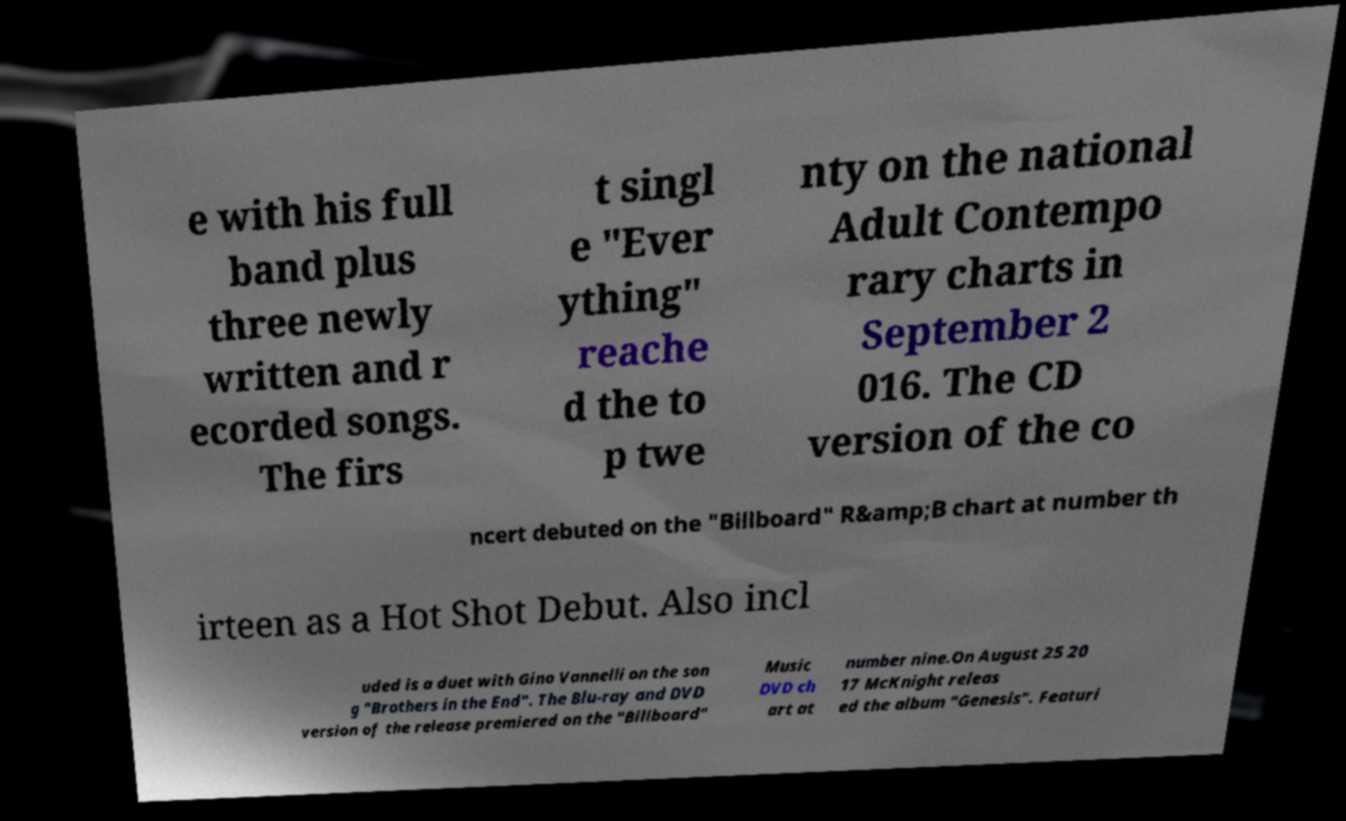There's text embedded in this image that I need extracted. Can you transcribe it verbatim? e with his full band plus three newly written and r ecorded songs. The firs t singl e "Ever ything" reache d the to p twe nty on the national Adult Contempo rary charts in September 2 016. The CD version of the co ncert debuted on the "Billboard" R&amp;B chart at number th irteen as a Hot Shot Debut. Also incl uded is a duet with Gino Vannelli on the son g "Brothers in the End". The Blu-ray and DVD version of the release premiered on the "Billboard" Music DVD ch art at number nine.On August 25 20 17 McKnight releas ed the album "Genesis". Featuri 